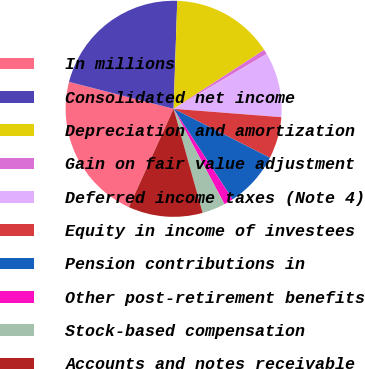Convert chart to OTSL. <chart><loc_0><loc_0><loc_500><loc_500><pie_chart><fcel>In millions<fcel>Consolidated net income<fcel>Depreciation and amortization<fcel>Gain on fair value adjustment<fcel>Deferred income taxes (Note 4)<fcel>Equity in income of investees<fcel>Pension contributions in<fcel>Other post-retirement benefits<fcel>Stock-based compensation<fcel>Accounts and notes receivable<nl><fcel>22.22%<fcel>21.52%<fcel>15.28%<fcel>0.7%<fcel>9.72%<fcel>6.25%<fcel>8.33%<fcel>1.39%<fcel>3.47%<fcel>11.11%<nl></chart> 